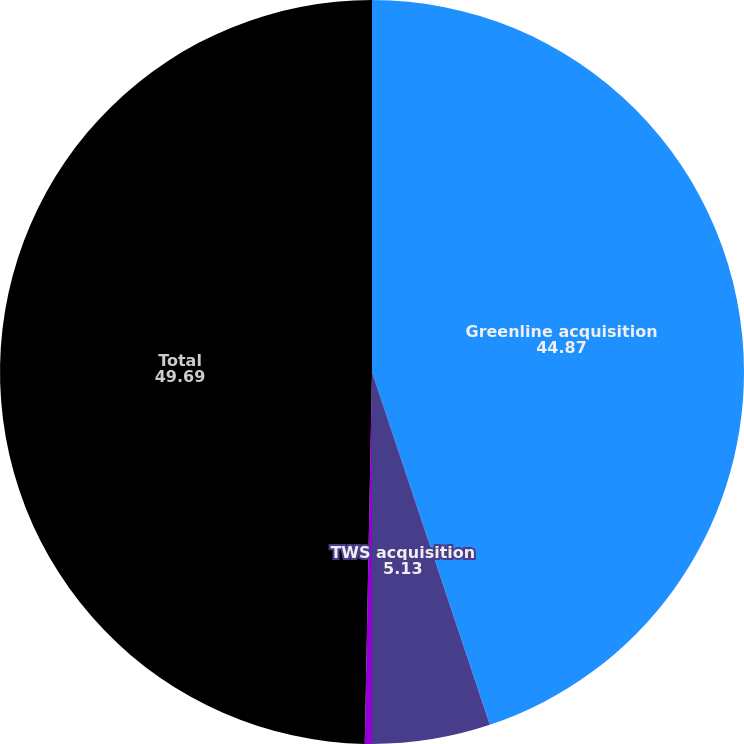Convert chart. <chart><loc_0><loc_0><loc_500><loc_500><pie_chart><fcel>Greenline acquisition<fcel>TWS acquisition<fcel>Other<fcel>Total<nl><fcel>44.87%<fcel>5.13%<fcel>0.31%<fcel>49.69%<nl></chart> 